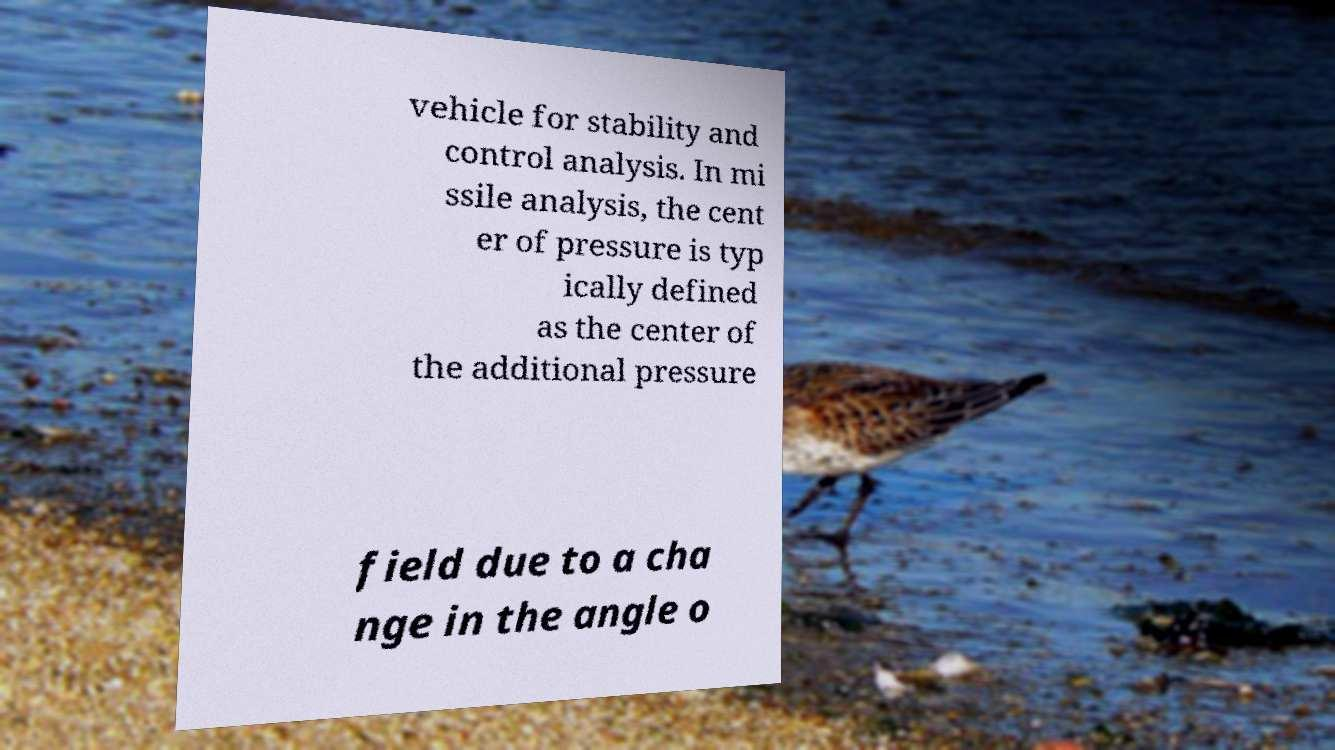Could you assist in decoding the text presented in this image and type it out clearly? vehicle for stability and control analysis. In mi ssile analysis, the cent er of pressure is typ ically defined as the center of the additional pressure field due to a cha nge in the angle o 